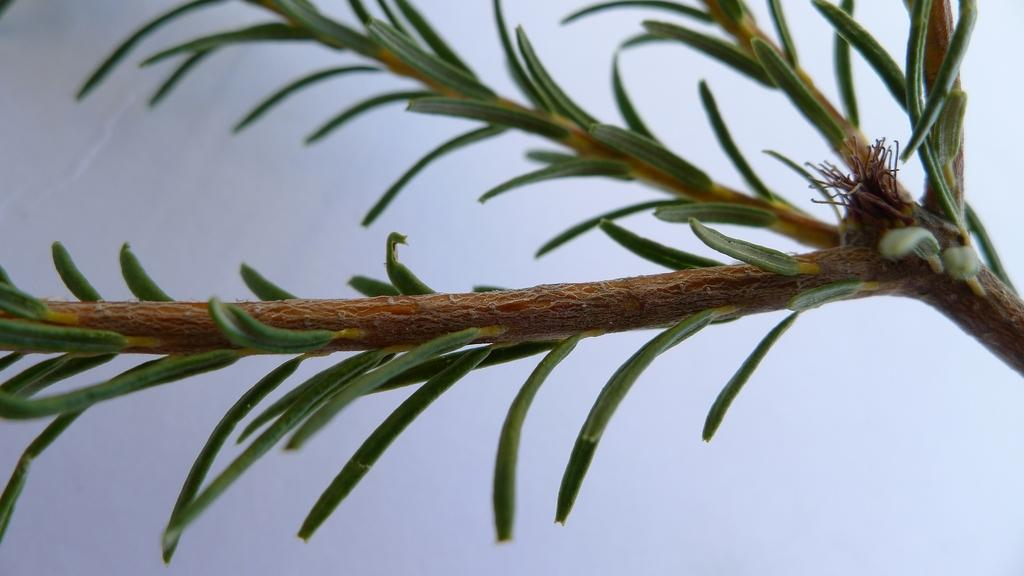What is the main subject of the picture? The main subject of the picture is a stem. What can be observed about the stem? The stem has leaves. What can be seen in the background of the picture? There is a wall in the background of the picture. What type of sleet can be seen falling from the leaves in the image? There is no sleet present in the image; it only features a stem with leaves and a wall in the background. Who is the creator of the stem in the image? The image does not provide information about the creator of the stem, as it is a natural object. 